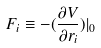<formula> <loc_0><loc_0><loc_500><loc_500>F _ { i } \equiv - ( \frac { \partial V } { \partial r _ { i } } ) | _ { 0 }</formula> 